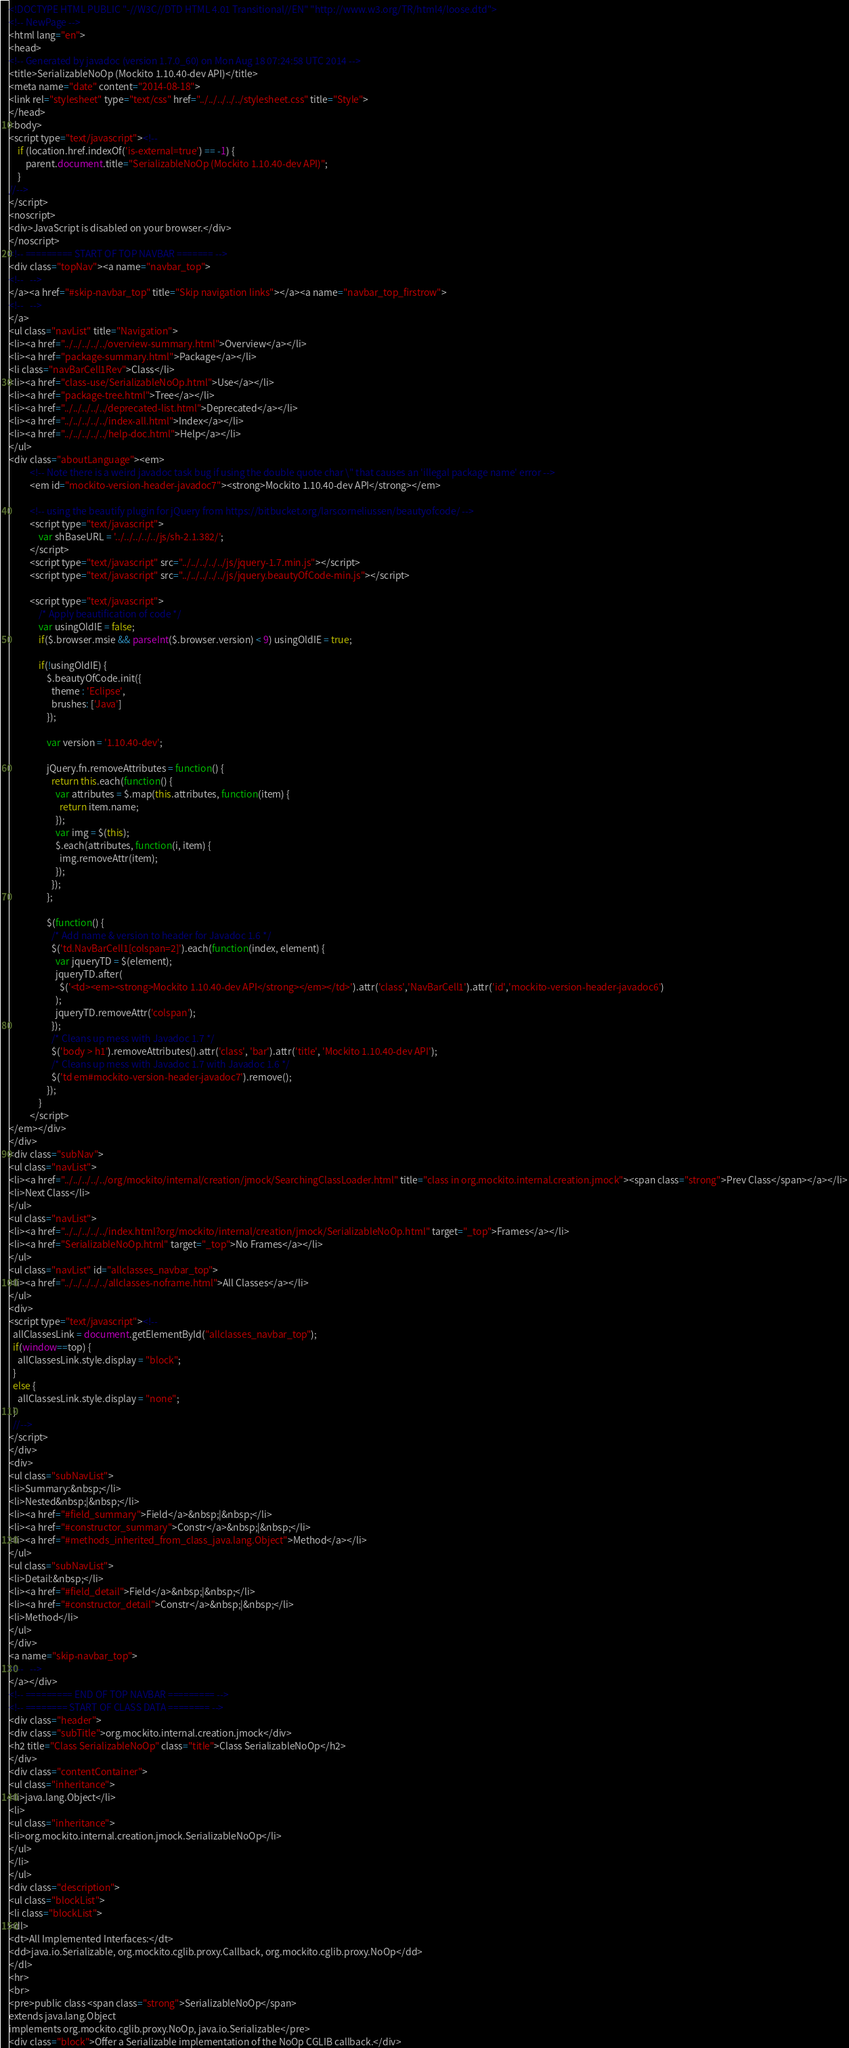Convert code to text. <code><loc_0><loc_0><loc_500><loc_500><_HTML_><!DOCTYPE HTML PUBLIC "-//W3C//DTD HTML 4.01 Transitional//EN" "http://www.w3.org/TR/html4/loose.dtd">
<!-- NewPage -->
<html lang="en">
<head>
<!-- Generated by javadoc (version 1.7.0_60) on Mon Aug 18 07:24:58 UTC 2014 -->
<title>SerializableNoOp (Mockito 1.10.40-dev API)</title>
<meta name="date" content="2014-08-18">
<link rel="stylesheet" type="text/css" href="../../../../../stylesheet.css" title="Style">
</head>
<body>
<script type="text/javascript"><!--
    if (location.href.indexOf('is-external=true') == -1) {
        parent.document.title="SerializableNoOp (Mockito 1.10.40-dev API)";
    }
//-->
</script>
<noscript>
<div>JavaScript is disabled on your browser.</div>
</noscript>
<!-- ========= START OF TOP NAVBAR ======= -->
<div class="topNav"><a name="navbar_top">
<!--   -->
</a><a href="#skip-navbar_top" title="Skip navigation links"></a><a name="navbar_top_firstrow">
<!--   -->
</a>
<ul class="navList" title="Navigation">
<li><a href="../../../../../overview-summary.html">Overview</a></li>
<li><a href="package-summary.html">Package</a></li>
<li class="navBarCell1Rev">Class</li>
<li><a href="class-use/SerializableNoOp.html">Use</a></li>
<li><a href="package-tree.html">Tree</a></li>
<li><a href="../../../../../deprecated-list.html">Deprecated</a></li>
<li><a href="../../../../../index-all.html">Index</a></li>
<li><a href="../../../../../help-doc.html">Help</a></li>
</ul>
<div class="aboutLanguage"><em>
          <!-- Note there is a weird javadoc task bug if using the double quote char \" that causes an 'illegal package name' error -->
          <em id="mockito-version-header-javadoc7"><strong>Mockito 1.10.40-dev API</strong></em>

          <!-- using the beautify plugin for jQuery from https://bitbucket.org/larscorneliussen/beautyofcode/ -->
          <script type="text/javascript">
              var shBaseURL = '../../../../../js/sh-2.1.382/';
          </script>
          <script type="text/javascript" src="../../../../../js/jquery-1.7.min.js"></script>
          <script type="text/javascript" src="../../../../../js/jquery.beautyOfCode-min.js"></script>

          <script type="text/javascript">
              /* Apply beautification of code */
              var usingOldIE = false;
              if($.browser.msie && parseInt($.browser.version) < 9) usingOldIE = true;

              if(!usingOldIE) {
                  $.beautyOfCode.init({
                    theme : 'Eclipse',
                    brushes: ['Java']
                  });

                  var version = '1.10.40-dev';

                  jQuery.fn.removeAttributes = function() {
                    return this.each(function() {
                      var attributes = $.map(this.attributes, function(item) {
                        return item.name;
                      });
                      var img = $(this);
                      $.each(attributes, function(i, item) {
                        img.removeAttr(item);
                      });
                    });
                  };

                  $(function() {
                    /* Add name & version to header for Javadoc 1.6 */
                    $('td.NavBarCell1[colspan=2]').each(function(index, element) {
                      var jqueryTD = $(element);
                      jqueryTD.after(
                        $('<td><em><strong>Mockito 1.10.40-dev API</strong></em></td>').attr('class','NavBarCell1').attr('id','mockito-version-header-javadoc6')
                      );
                      jqueryTD.removeAttr('colspan');
                    });
                    /* Cleans up mess with Javadoc 1.7 */
                    $('body > h1').removeAttributes().attr('class', 'bar').attr('title', 'Mockito 1.10.40-dev API');
                    /* Cleans up mess with Javadoc 1.7 with Javadoc 1.6 */
                    $('td em#mockito-version-header-javadoc7').remove();
                  });
              }
          </script>
</em></div>
</div>
<div class="subNav">
<ul class="navList">
<li><a href="../../../../../org/mockito/internal/creation/jmock/SearchingClassLoader.html" title="class in org.mockito.internal.creation.jmock"><span class="strong">Prev Class</span></a></li>
<li>Next Class</li>
</ul>
<ul class="navList">
<li><a href="../../../../../index.html?org/mockito/internal/creation/jmock/SerializableNoOp.html" target="_top">Frames</a></li>
<li><a href="SerializableNoOp.html" target="_top">No Frames</a></li>
</ul>
<ul class="navList" id="allclasses_navbar_top">
<li><a href="../../../../../allclasses-noframe.html">All Classes</a></li>
</ul>
<div>
<script type="text/javascript"><!--
  allClassesLink = document.getElementById("allclasses_navbar_top");
  if(window==top) {
    allClassesLink.style.display = "block";
  }
  else {
    allClassesLink.style.display = "none";
  }
  //-->
</script>
</div>
<div>
<ul class="subNavList">
<li>Summary:&nbsp;</li>
<li>Nested&nbsp;|&nbsp;</li>
<li><a href="#field_summary">Field</a>&nbsp;|&nbsp;</li>
<li><a href="#constructor_summary">Constr</a>&nbsp;|&nbsp;</li>
<li><a href="#methods_inherited_from_class_java.lang.Object">Method</a></li>
</ul>
<ul class="subNavList">
<li>Detail:&nbsp;</li>
<li><a href="#field_detail">Field</a>&nbsp;|&nbsp;</li>
<li><a href="#constructor_detail">Constr</a>&nbsp;|&nbsp;</li>
<li>Method</li>
</ul>
</div>
<a name="skip-navbar_top">
<!--   -->
</a></div>
<!-- ========= END OF TOP NAVBAR ========= -->
<!-- ======== START OF CLASS DATA ======== -->
<div class="header">
<div class="subTitle">org.mockito.internal.creation.jmock</div>
<h2 title="Class SerializableNoOp" class="title">Class SerializableNoOp</h2>
</div>
<div class="contentContainer">
<ul class="inheritance">
<li>java.lang.Object</li>
<li>
<ul class="inheritance">
<li>org.mockito.internal.creation.jmock.SerializableNoOp</li>
</ul>
</li>
</ul>
<div class="description">
<ul class="blockList">
<li class="blockList">
<dl>
<dt>All Implemented Interfaces:</dt>
<dd>java.io.Serializable, org.mockito.cglib.proxy.Callback, org.mockito.cglib.proxy.NoOp</dd>
</dl>
<hr>
<br>
<pre>public class <span class="strong">SerializableNoOp</span>
extends java.lang.Object
implements org.mockito.cglib.proxy.NoOp, java.io.Serializable</pre>
<div class="block">Offer a Serializable implementation of the NoOp CGLIB callback.</div></code> 